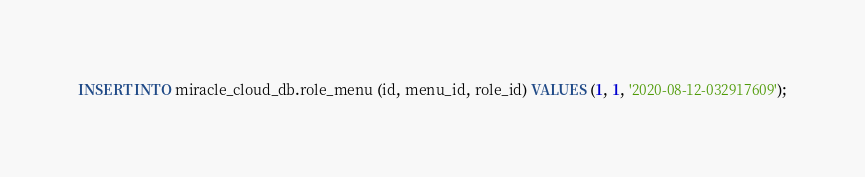<code> <loc_0><loc_0><loc_500><loc_500><_SQL_>INSERT INTO miracle_cloud_db.role_menu (id, menu_id, role_id) VALUES (1, 1, '2020-08-12-032917609');</code> 